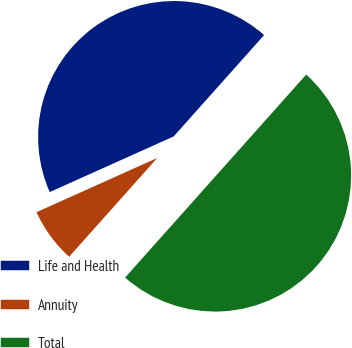<chart> <loc_0><loc_0><loc_500><loc_500><pie_chart><fcel>Life and Health<fcel>Annuity<fcel>Total<nl><fcel>43.31%<fcel>6.69%<fcel>50.0%<nl></chart> 